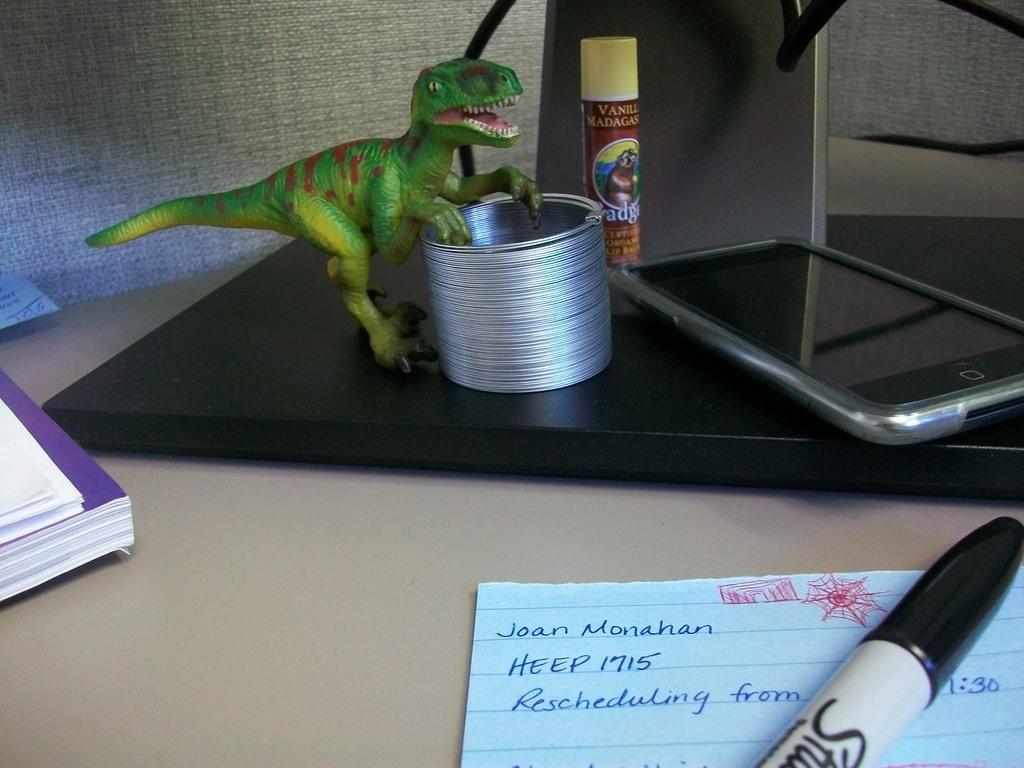Could you give a brief overview of what you see in this image? In this image we can see a paper on which we can see some note is written, we can see the pen, a book, mobile phone, a toy and few more things are kept on the surface. 